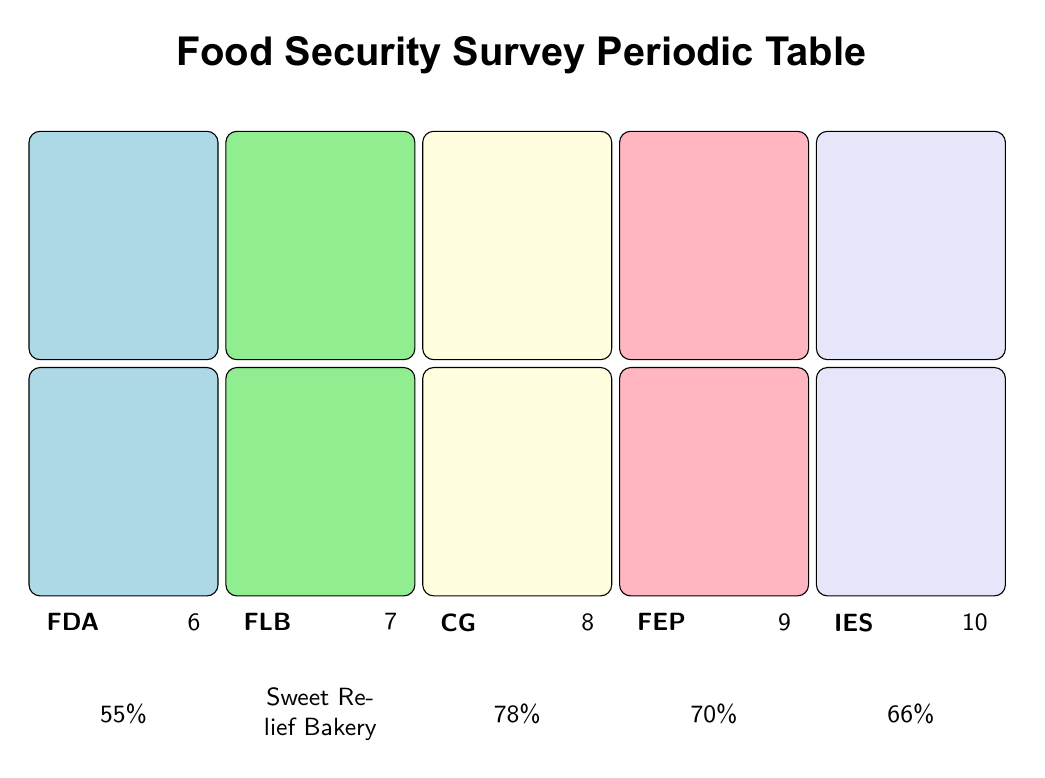What percentage of community members support local food assistance programs? The table states that 85% of community members support local food assistance programs under the element "Support for Food Programs."
Answer: 85% What is the most favorite local bakery mentioned among survey respondents? According to the table, the most mentioned local bakery is "Sweet Relief Bakery" under the element "Favorite Local Bakery."
Answer: Sweet Relief Bakery Is the percentage of respondents indicating economic factors as a barrier to food security greater than 60%? The table shows that 66% of respondents indicate economic factors as a barrier to food security, which is greater than 60%.
Answer: Yes What is the average percentage of community members aware of food security issues and those who believe community gardens aid in food security? The two percentages are 72% (Community Awareness) and 78% (Importance of Community Gardens). To find the average: (72 + 78) / 2 = 150 / 2 = 75%.
Answer: 75% How many community members are aware of food donation opportunities compared to those actively volunteering for food-related initiatives? The percentage of community members aware of food donation opportunities is 55%, while those actively volunteering for food-related initiatives is 40%. Comparatively, 55% is greater than 40%.
Answer: 55% is greater than 40% What percentage of residents believe their food security status is at risk? The table indicates that 30% of residents believe their food security status is at risk under the element "Perceived Food Insecurity."
Answer: 30% How many more community members support local food assistance programs than those actively participating as volunteers? Support for local food assistance programs is at 85% and volunteer participation is 40%. The difference is 85% - 40% = 45%.
Answer: 45% What percentage of residents favor food literacy and cooking classes? According to the table, 70% of participants favor food literacy and cooking classes under the element "Food Education Programs."
Answer: 70% 